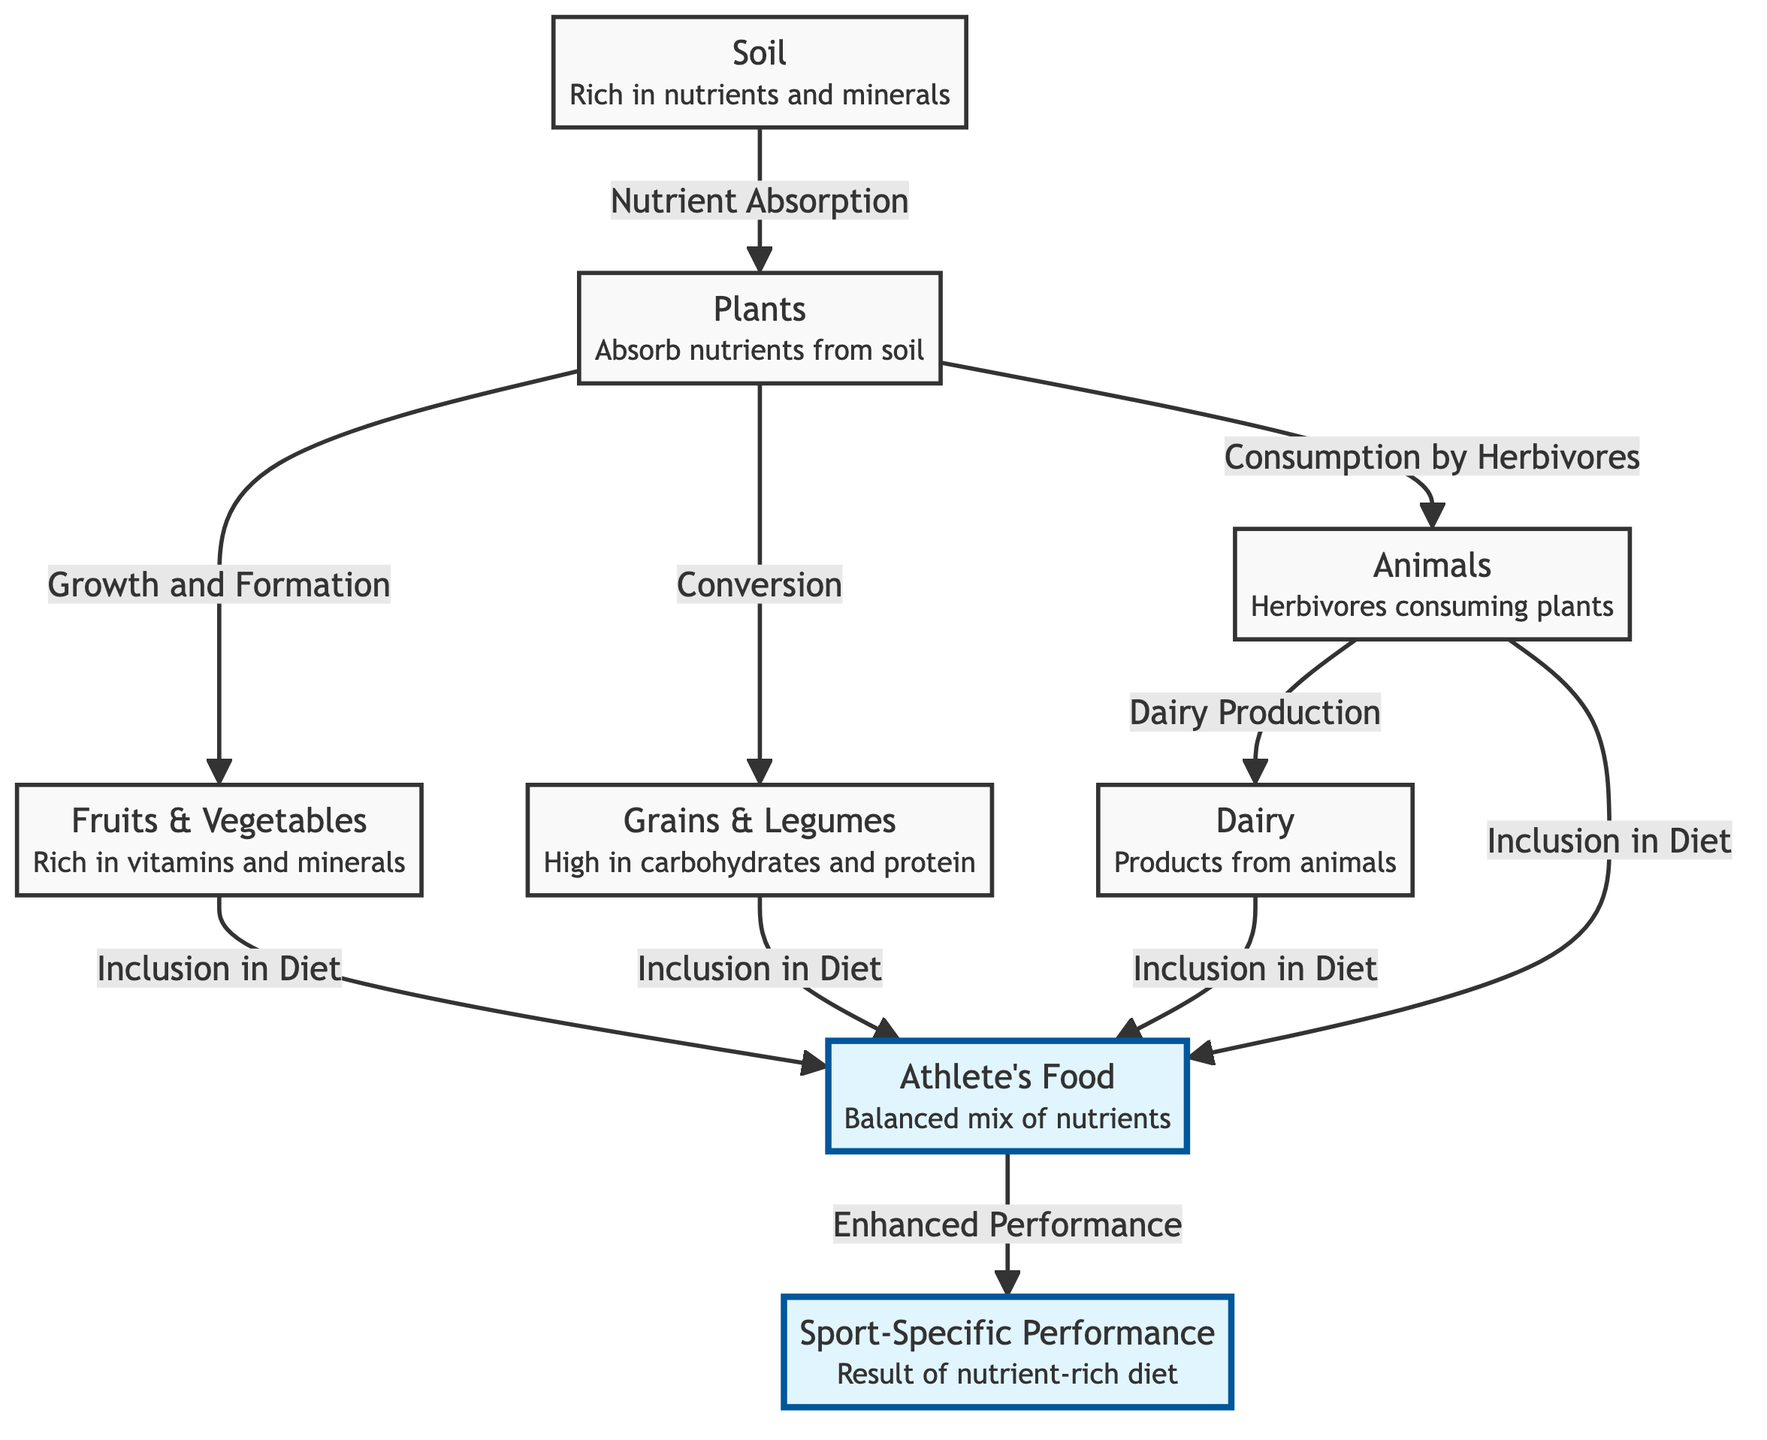What is the first element in the food chain? The diagram indicates that the first element in the food chain is "Soil," which provides the necessary nutrients and minerals essential for plant growth.
Answer: Soil How many types of food sources are included for athletes? The diagram lists four food sources for athletes: "Fruits & Vegetables," "Grains & Legumes," "Dairy," and "Animals." Each of these contributes to the athlete's diet.
Answer: 4 What is absorbed by plants from the soil? According to the diagram, plants absorb "nutrients" from the soil, which is crucial for their growth and health.
Answer: Nutrients Which category directly leads to "Sport-Specific Performance"? The direct path from "Athlete's Food" to "Sport-Specific Performance" indicates that the elements of an athlete's diet are what enhance their performance.
Answer: Athlete's Food How do animals contribute to the food chain? Animals consume plants, which positions them as herbivores in the food chain; they also produce dairy products that become part of the athlete's diet.
Answer: Herbivores What role do fruits and vegetables play in the food chain? Fruits and vegetables are derived from plants and hold important vitamins and minerals, which are included in the diet of athletes to enhance their performance.
Answer: Vitamins and minerals How does nutrient absorption initiate the food chain? The flowchart shows that nutrient absorption occurs when plants take up nutrients from the soil, creating a foundation for the subsequent stages in the chain.
Answer: Nutrient Absorption Why are grains and legumes significant to athletes? Grains and legumes provide essential carbohydrates and proteins, which are vital for energy and muscle recovery, making them significant for athletes.
Answer: Carbohydrates and protein What is the relationship between dairy and athletes' food? Dairy is included in the athlete's food, indicating that products from animals contribute to the balanced diet necessary for athletic performance.
Answer: Inclusion in Diet 